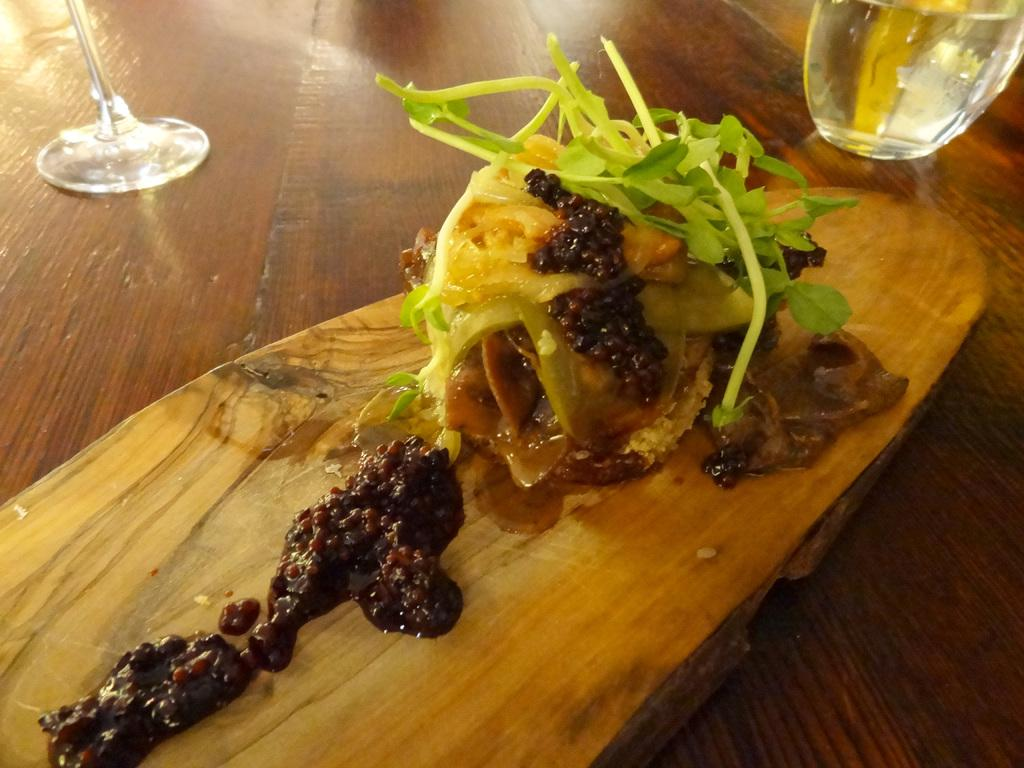What piece of furniture is present in the image? There is a table in the image. What is placed on the table? There is a glass of water, a wine glass, and a food item on a platter on the table. What type of ornament is hanging from the ceiling in the image? There is no ornament hanging from the ceiling in the image; the facts provided only mention items on the table. 